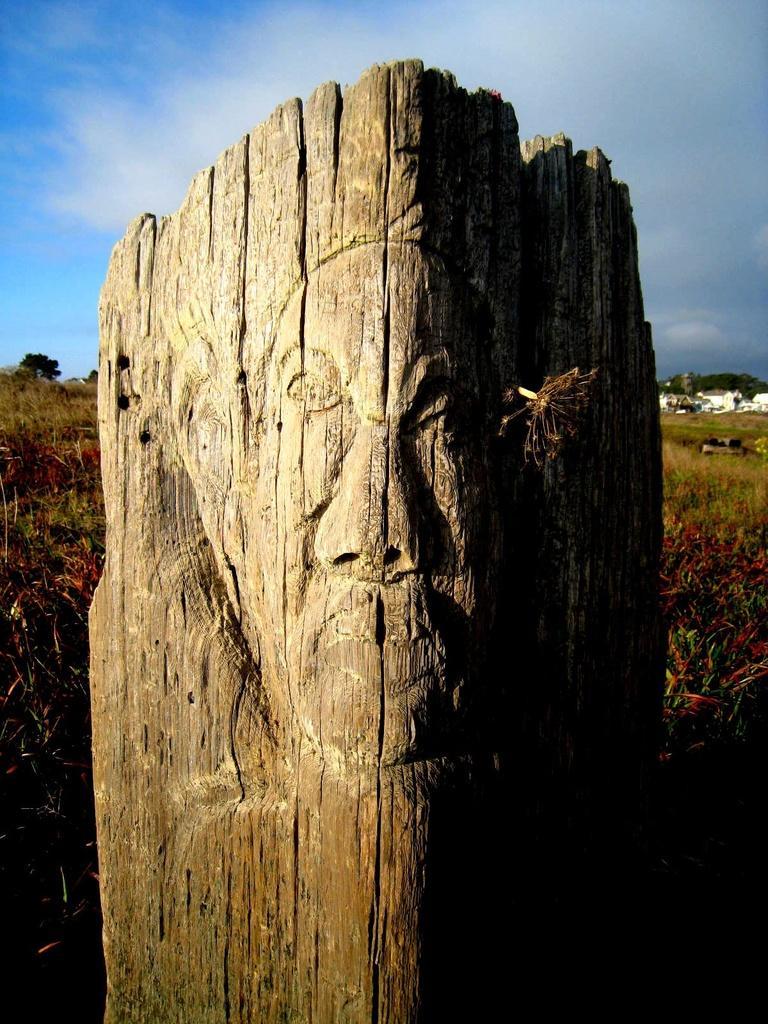How would you summarize this image in a sentence or two? This is wood carving. Background there is a grass. Sky is cloudy. 